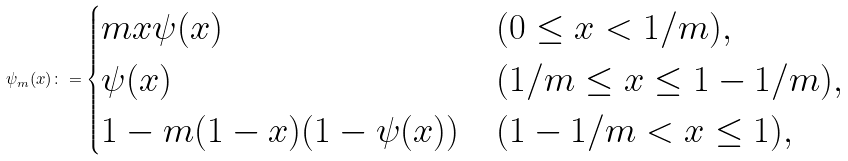<formula> <loc_0><loc_0><loc_500><loc_500>\psi _ { m } ( x ) \colon = \begin{cases} m x \psi ( x ) & ( 0 \leq x < 1 / m ) , \\ \psi ( x ) & ( 1 / m \leq x \leq 1 - 1 / m ) , \\ 1 - m ( 1 - x ) ( 1 - \psi ( x ) ) & ( 1 - 1 / m < x \leq 1 ) , \end{cases}</formula> 